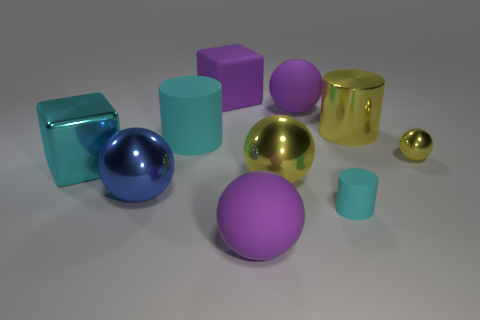What size is the blue ball that is made of the same material as the small yellow ball?
Your answer should be compact. Large. Do the big cyan object that is behind the large cyan block and the small object to the left of the tiny yellow metallic ball have the same material?
Your answer should be very brief. Yes. How many cubes are small cyan things or large purple matte objects?
Offer a very short reply. 1. There is a cube that is behind the large shiny thing that is behind the cyan metallic thing; how many purple matte things are behind it?
Offer a very short reply. 0. There is a purple object that is the same shape as the cyan metallic object; what is its material?
Keep it short and to the point. Rubber. Is there anything else that is the same material as the tiny cyan thing?
Ensure brevity in your answer.  Yes. What color is the large rubber object in front of the large yellow sphere?
Make the answer very short. Purple. Does the tiny yellow ball have the same material as the big yellow thing on the right side of the small rubber cylinder?
Your answer should be very brief. Yes. What is the big cyan cube made of?
Offer a very short reply. Metal. There is a tiny object that is the same material as the large purple block; what is its shape?
Your response must be concise. Cylinder. 